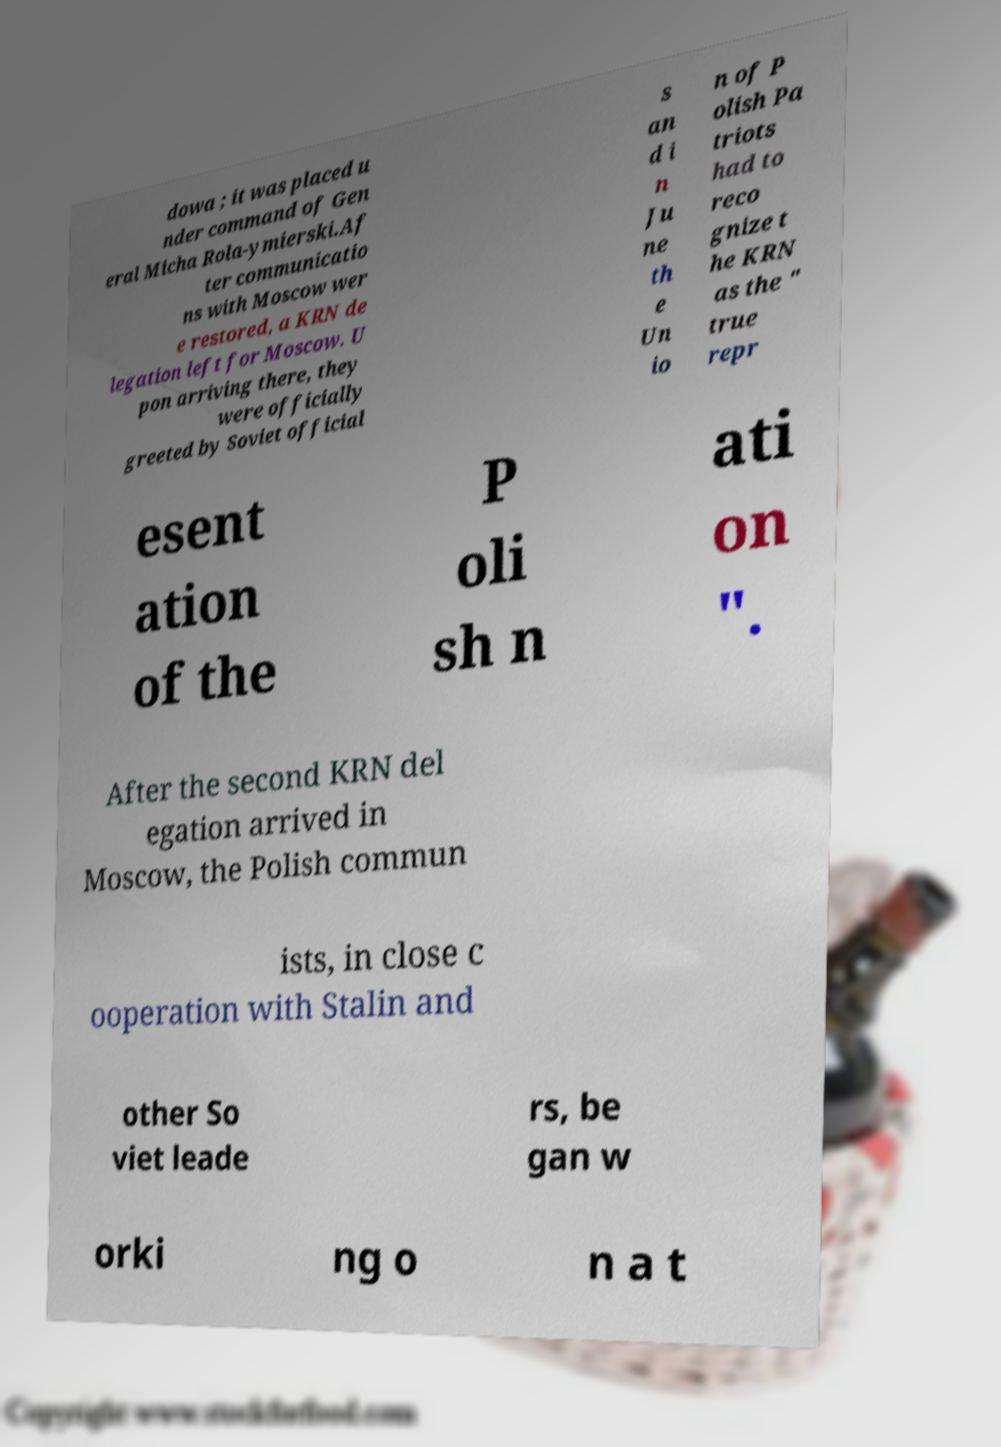Please identify and transcribe the text found in this image. dowa ; it was placed u nder command of Gen eral Micha Rola-ymierski.Af ter communicatio ns with Moscow wer e restored, a KRN de legation left for Moscow. U pon arriving there, they were officially greeted by Soviet official s an d i n Ju ne th e Un io n of P olish Pa triots had to reco gnize t he KRN as the " true repr esent ation of the P oli sh n ati on ". After the second KRN del egation arrived in Moscow, the Polish commun ists, in close c ooperation with Stalin and other So viet leade rs, be gan w orki ng o n a t 